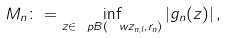Convert formula to latex. <formula><loc_0><loc_0><loc_500><loc_500>M _ { n } \colon = \inf _ { z \in \ p B ( \ w { z } _ { n , l } , r _ { n } ) } | g _ { n } ( z ) | \, ,</formula> 